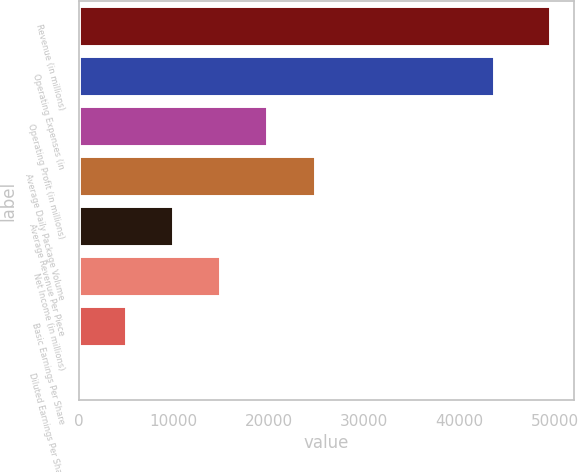Convert chart. <chart><loc_0><loc_0><loc_500><loc_500><bar_chart><fcel>Revenue (in millions)<fcel>Operating Expenses (in<fcel>Operating Profit (in millions)<fcel>Average Daily Package Volume<fcel>Average Revenue Per Piece<fcel>Net Income (in millions)<fcel>Basic Earnings Per Share<fcel>Diluted Earnings Per Share<nl><fcel>49545<fcel>43671<fcel>19820.1<fcel>24774.2<fcel>9911.78<fcel>14865.9<fcel>4957.63<fcel>3.48<nl></chart> 